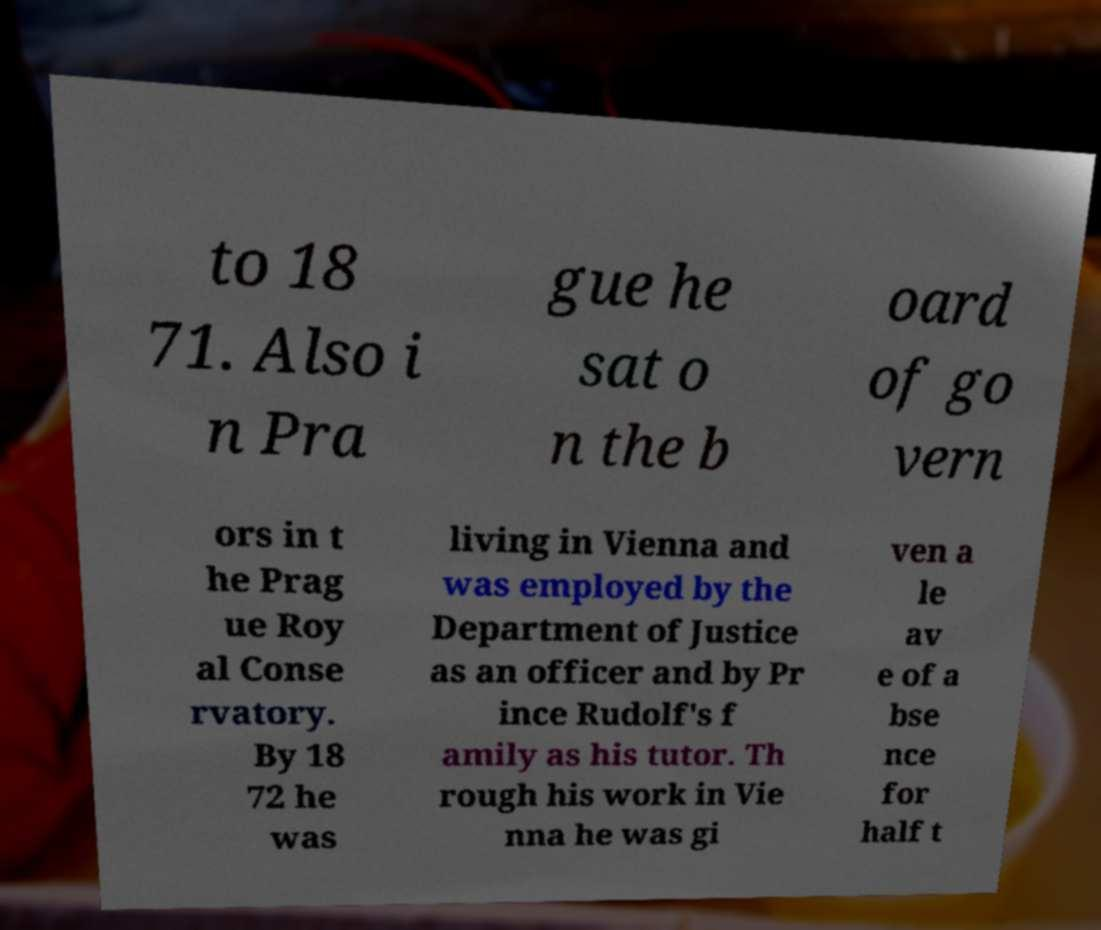Could you assist in decoding the text presented in this image and type it out clearly? to 18 71. Also i n Pra gue he sat o n the b oard of go vern ors in t he Prag ue Roy al Conse rvatory. By 18 72 he was living in Vienna and was employed by the Department of Justice as an officer and by Pr ince Rudolf's f amily as his tutor. Th rough his work in Vie nna he was gi ven a le av e of a bse nce for half t 